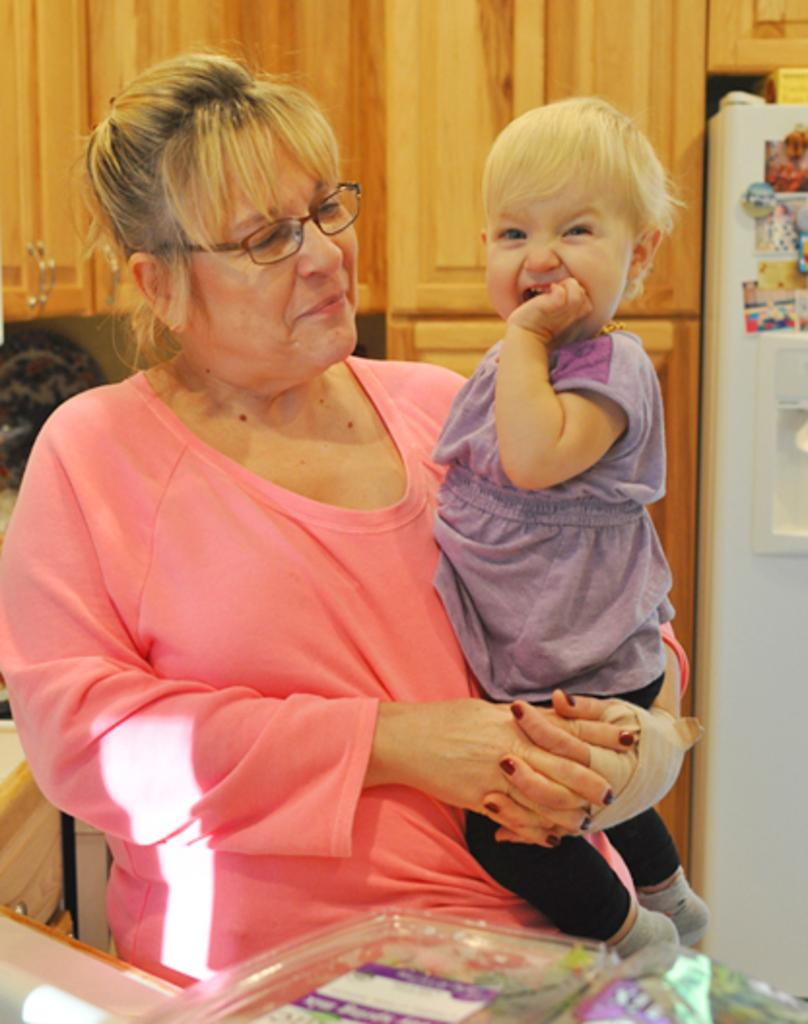Who is the main subject in the image? There is a woman in the image. What is the woman doing in the image? The woman is carrying a baby. Can you describe the woman's appearance? The woman is wearing spectacles. What can be seen in the background of the image? There are cupboards and a fridge in the background of the image. Can you tell me how many kisses the woman gives to the baby in the image? There is no indication of kisses being given in the image; it only shows the woman carrying the baby. What type of test is the woman taking in the image? There is no test present in the image; the woman is simply carrying a baby. 